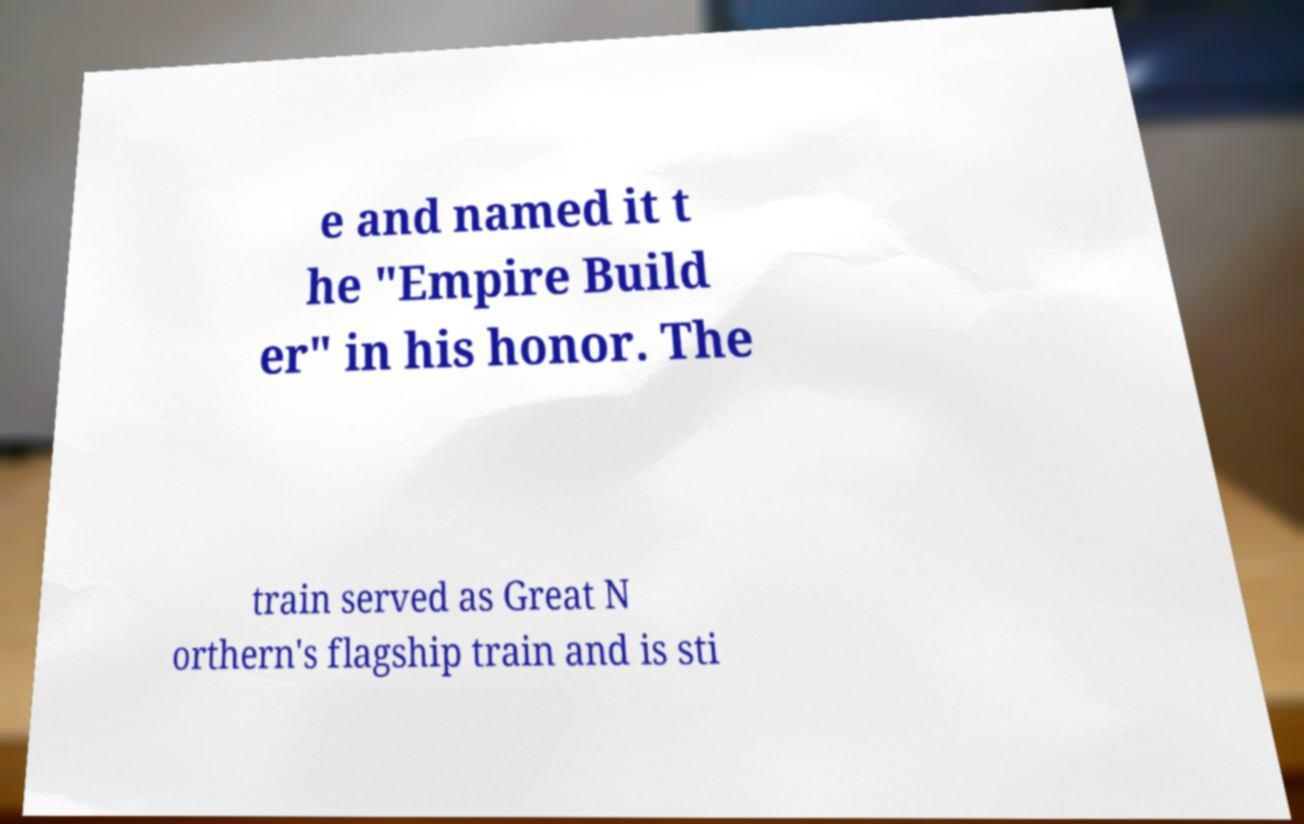I need the written content from this picture converted into text. Can you do that? e and named it t he "Empire Build er" in his honor. The train served as Great N orthern's flagship train and is sti 